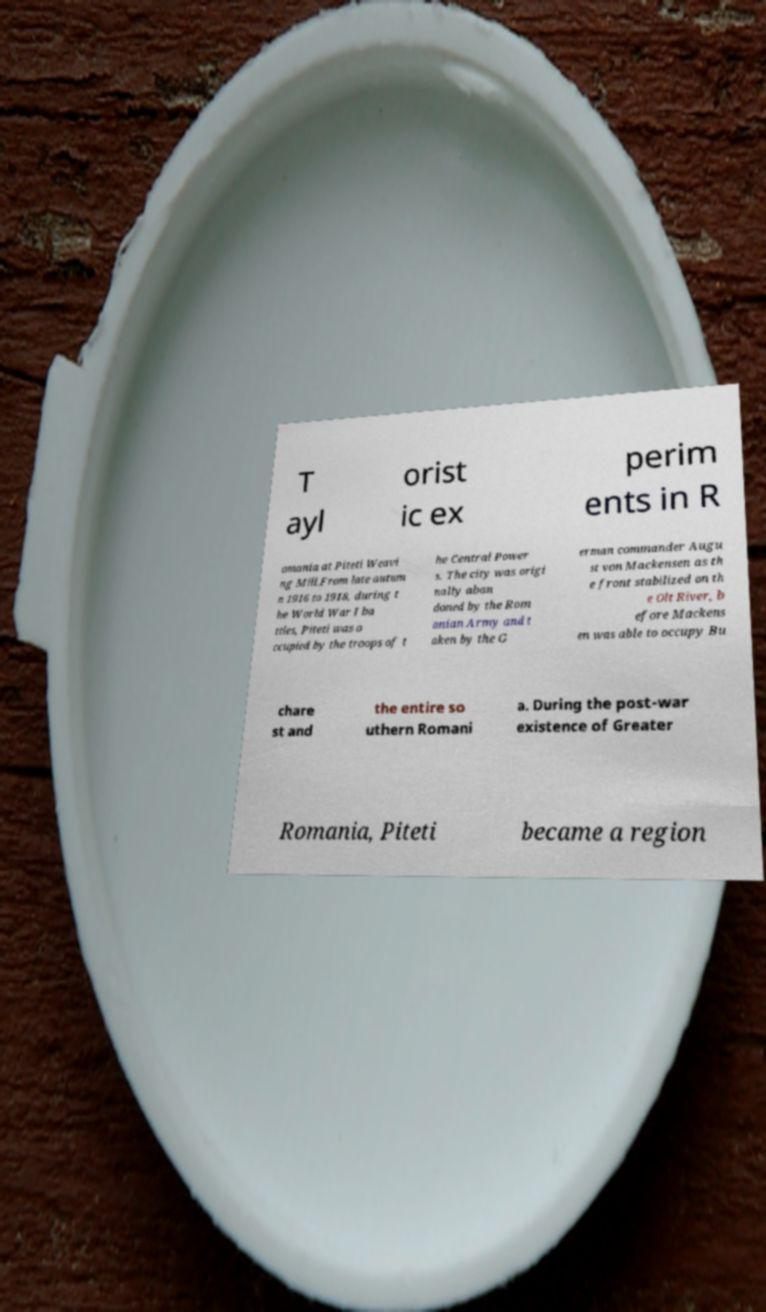There's text embedded in this image that I need extracted. Can you transcribe it verbatim? T ayl orist ic ex perim ents in R omania at Piteti Weavi ng Mill.From late autum n 1916 to 1918, during t he World War I ba ttles, Piteti was o ccupied by the troops of t he Central Power s. The city was origi nally aban doned by the Rom anian Army and t aken by the G erman commander Augu st von Mackensen as th e front stabilized on th e Olt River, b efore Mackens en was able to occupy Bu chare st and the entire so uthern Romani a. During the post-war existence of Greater Romania, Piteti became a region 